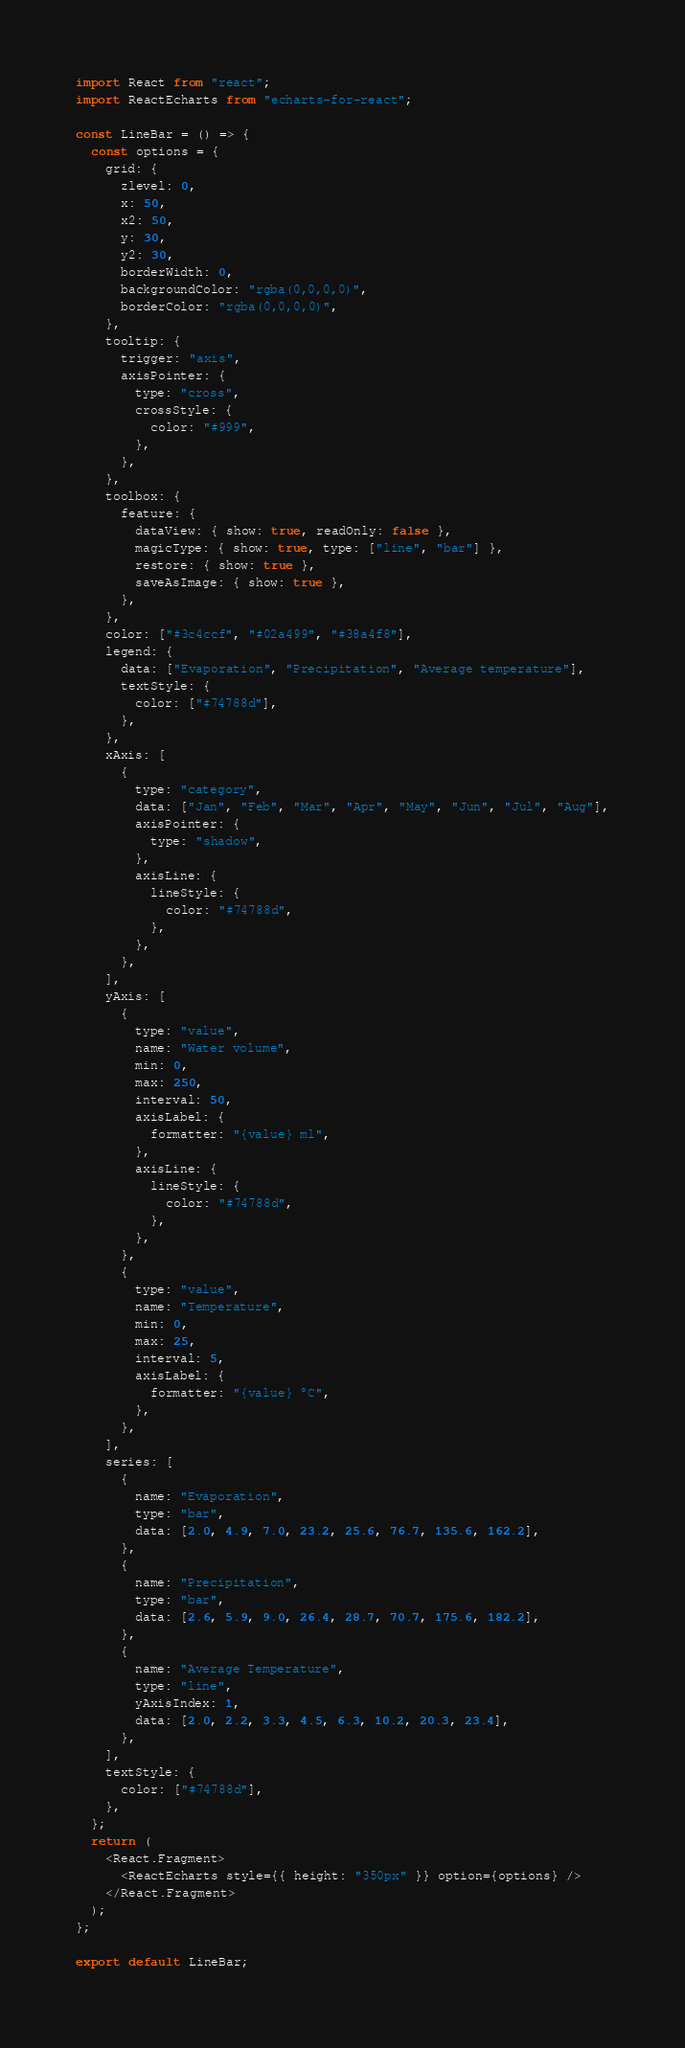<code> <loc_0><loc_0><loc_500><loc_500><_JavaScript_>import React from "react";
import ReactEcharts from "echarts-for-react";

const LineBar = () => {
  const options = {
    grid: {
      zlevel: 0,
      x: 50,
      x2: 50,
      y: 30,
      y2: 30,
      borderWidth: 0,
      backgroundColor: "rgba(0,0,0,0)",
      borderColor: "rgba(0,0,0,0)",
    },
    tooltip: {
      trigger: "axis",
      axisPointer: {
        type: "cross",
        crossStyle: {
          color: "#999",
        },
      },
    },
    toolbox: {
      feature: {
        dataView: { show: true, readOnly: false },
        magicType: { show: true, type: ["line", "bar"] },
        restore: { show: true },
        saveAsImage: { show: true },
      },
    },
    color: ["#3c4ccf", "#02a499", "#38a4f8"],
    legend: {
      data: ["Evaporation", "Precipitation", "Average temperature"],
      textStyle: {
        color: ["#74788d"],
      },
    },
    xAxis: [
      {
        type: "category",
        data: ["Jan", "Feb", "Mar", "Apr", "May", "Jun", "Jul", "Aug"],
        axisPointer: {
          type: "shadow",
        },
        axisLine: {
          lineStyle: {
            color: "#74788d",
          },
        },
      },
    ],
    yAxis: [
      {
        type: "value",
        name: "Water volume",
        min: 0,
        max: 250,
        interval: 50,
        axisLabel: {
          formatter: "{value} ml",
        },
        axisLine: {
          lineStyle: {
            color: "#74788d",
          },
        },
      },
      {
        type: "value",
        name: "Temperature",
        min: 0,
        max: 25,
        interval: 5,
        axisLabel: {
          formatter: "{value} °C",
        },
      },
    ],
    series: [
      {
        name: "Evaporation",
        type: "bar",
        data: [2.0, 4.9, 7.0, 23.2, 25.6, 76.7, 135.6, 162.2],
      },
      {
        name: "Precipitation",
        type: "bar",
        data: [2.6, 5.9, 9.0, 26.4, 28.7, 70.7, 175.6, 182.2],
      },
      {
        name: "Average Temperature",
        type: "line",
        yAxisIndex: 1,
        data: [2.0, 2.2, 3.3, 4.5, 6.3, 10.2, 20.3, 23.4],
      },
    ],
    textStyle: {
      color: ["#74788d"],
    },
  };
  return (
    <React.Fragment>
      <ReactEcharts style={{ height: "350px" }} option={options} />
    </React.Fragment>
  );
};

export default LineBar;
</code> 